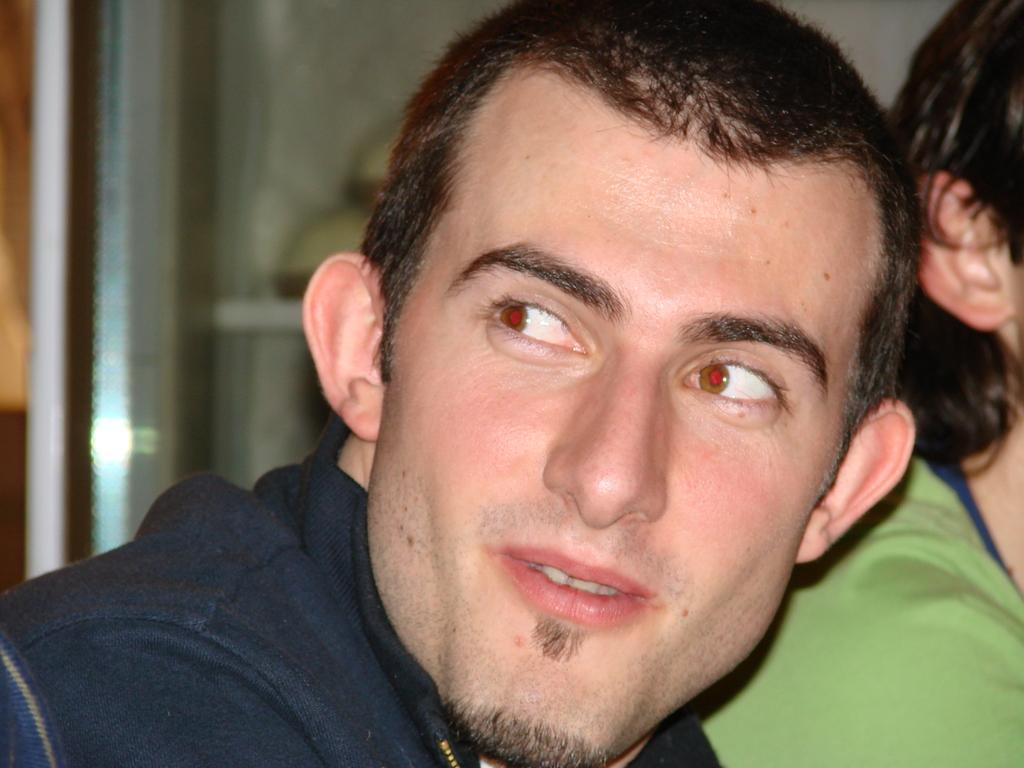How many people are in the image? There are two persons in the image. Can you describe the gender of one of the persons? One of the persons is a man. Where is the man positioned in the image? The man is in the front of the image. What is the man doing in the image? The man is looking at the man is looking at something. How would you describe the background of the image? The background of the image is blurry. Can you tell me how many snakes are present in the image? There are no snakes present in the image. What is the time of day depicted in the image? The provided facts do not give any information about the time of day, so it cannot be determined from the image. 